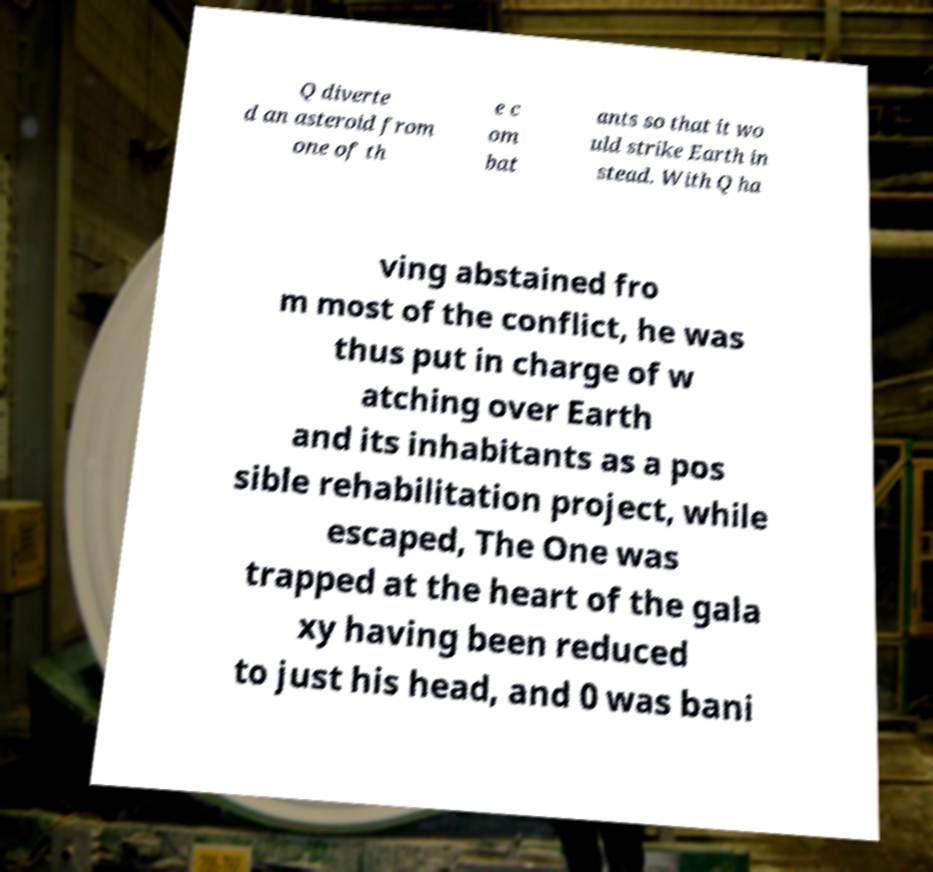Please read and relay the text visible in this image. What does it say? Q diverte d an asteroid from one of th e c om bat ants so that it wo uld strike Earth in stead. With Q ha ving abstained fro m most of the conflict, he was thus put in charge of w atching over Earth and its inhabitants as a pos sible rehabilitation project, while escaped, The One was trapped at the heart of the gala xy having been reduced to just his head, and 0 was bani 